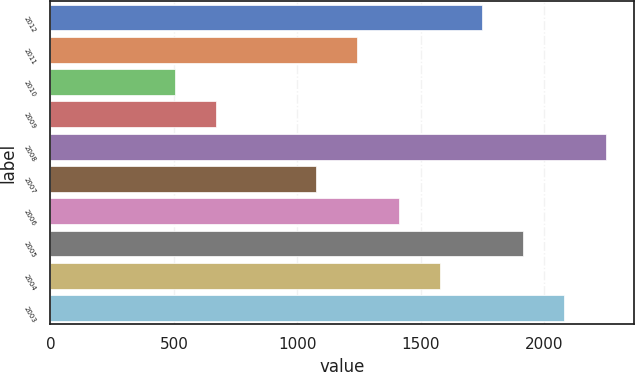Convert chart. <chart><loc_0><loc_0><loc_500><loc_500><bar_chart><fcel>2012<fcel>2011<fcel>2010<fcel>2009<fcel>2008<fcel>2007<fcel>2006<fcel>2005<fcel>2004<fcel>2003<nl><fcel>1745.8<fcel>1242.7<fcel>503<fcel>670.7<fcel>2248.9<fcel>1075<fcel>1410.4<fcel>1913.5<fcel>1578.1<fcel>2081.2<nl></chart> 